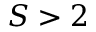Convert formula to latex. <formula><loc_0><loc_0><loc_500><loc_500>S > 2</formula> 